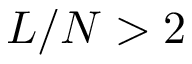<formula> <loc_0><loc_0><loc_500><loc_500>L / N > 2</formula> 